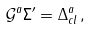Convert formula to latex. <formula><loc_0><loc_0><loc_500><loc_500>\mathcal { G } ^ { a } \Sigma ^ { \prime } = \Delta _ { c l } ^ { a } \, ,</formula> 